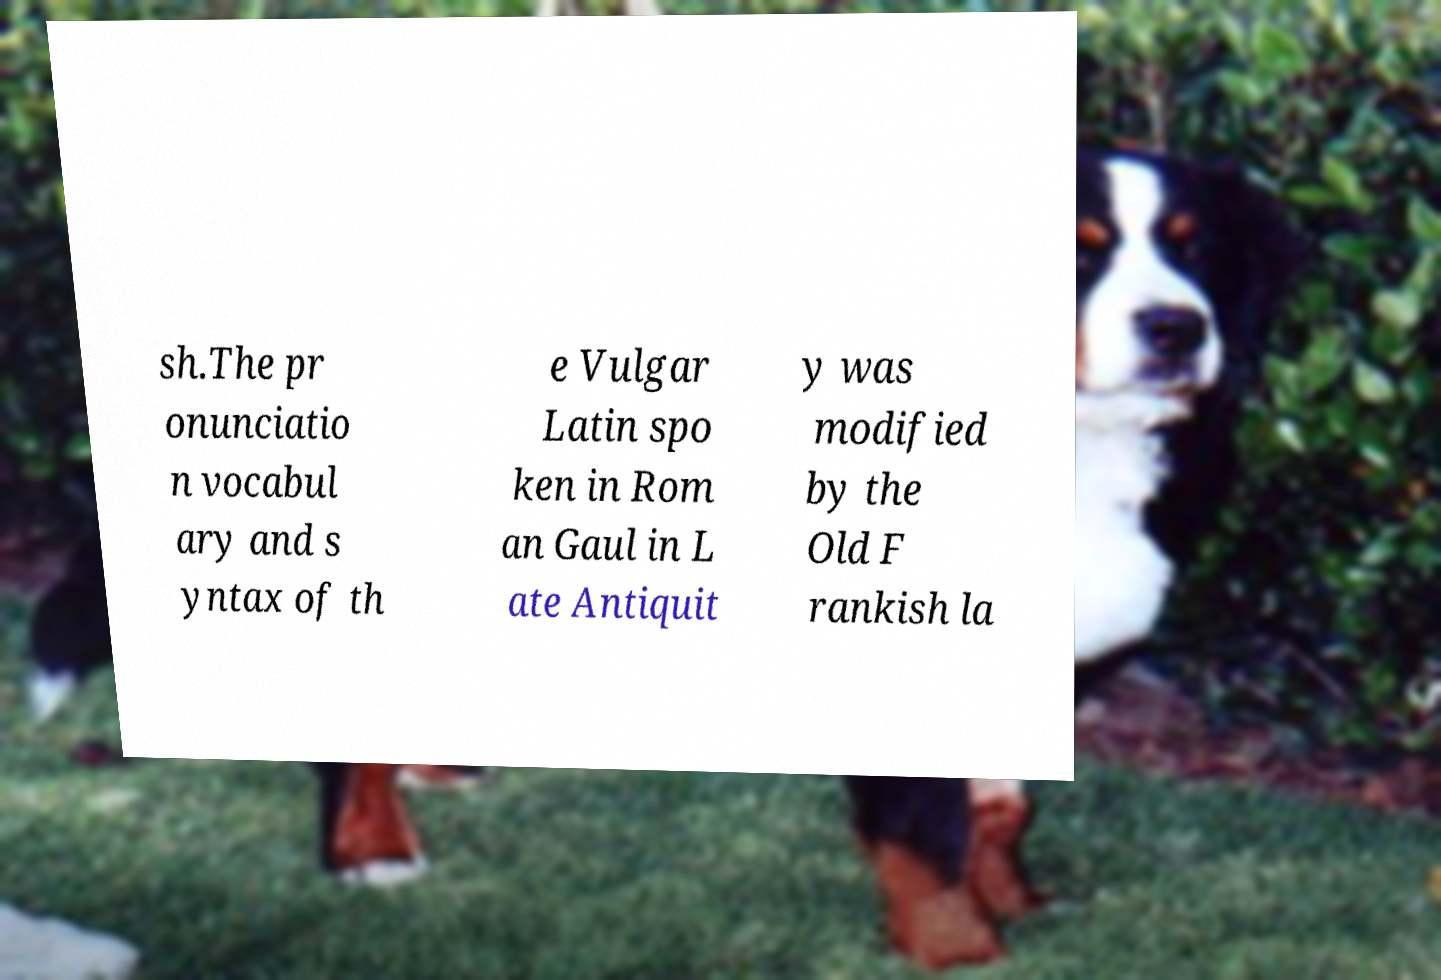Can you read and provide the text displayed in the image?This photo seems to have some interesting text. Can you extract and type it out for me? sh.The pr onunciatio n vocabul ary and s yntax of th e Vulgar Latin spo ken in Rom an Gaul in L ate Antiquit y was modified by the Old F rankish la 